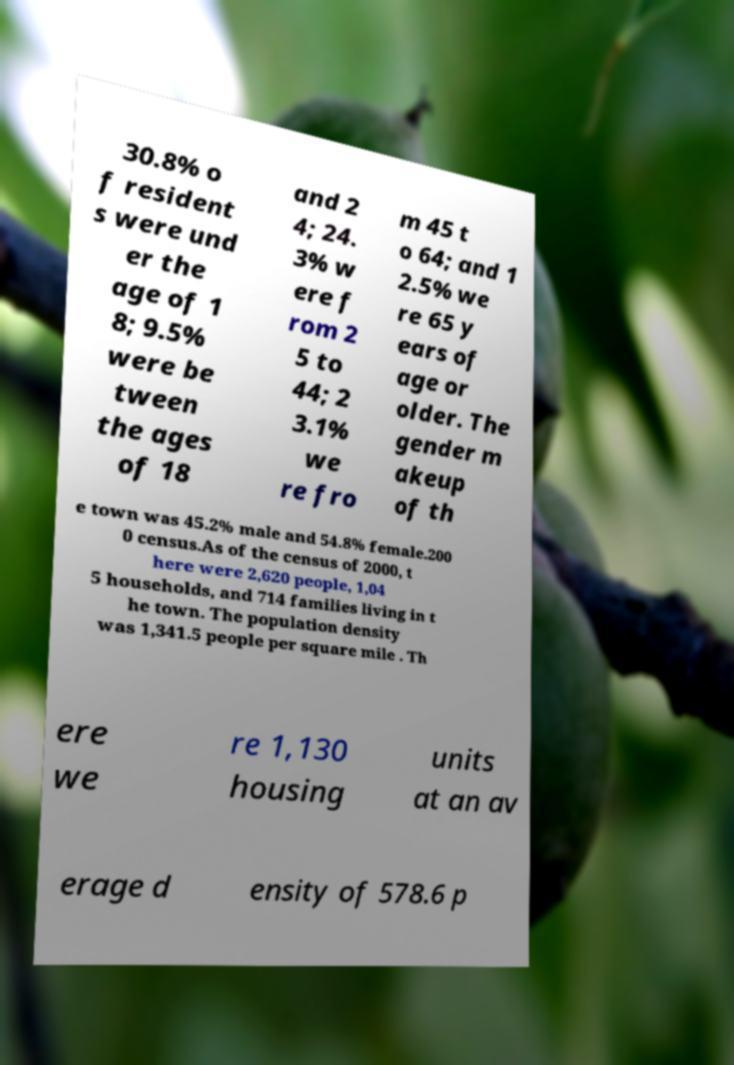For documentation purposes, I need the text within this image transcribed. Could you provide that? 30.8% o f resident s were und er the age of 1 8; 9.5% were be tween the ages of 18 and 2 4; 24. 3% w ere f rom 2 5 to 44; 2 3.1% we re fro m 45 t o 64; and 1 2.5% we re 65 y ears of age or older. The gender m akeup of th e town was 45.2% male and 54.8% female.200 0 census.As of the census of 2000, t here were 2,620 people, 1,04 5 households, and 714 families living in t he town. The population density was 1,341.5 people per square mile . Th ere we re 1,130 housing units at an av erage d ensity of 578.6 p 